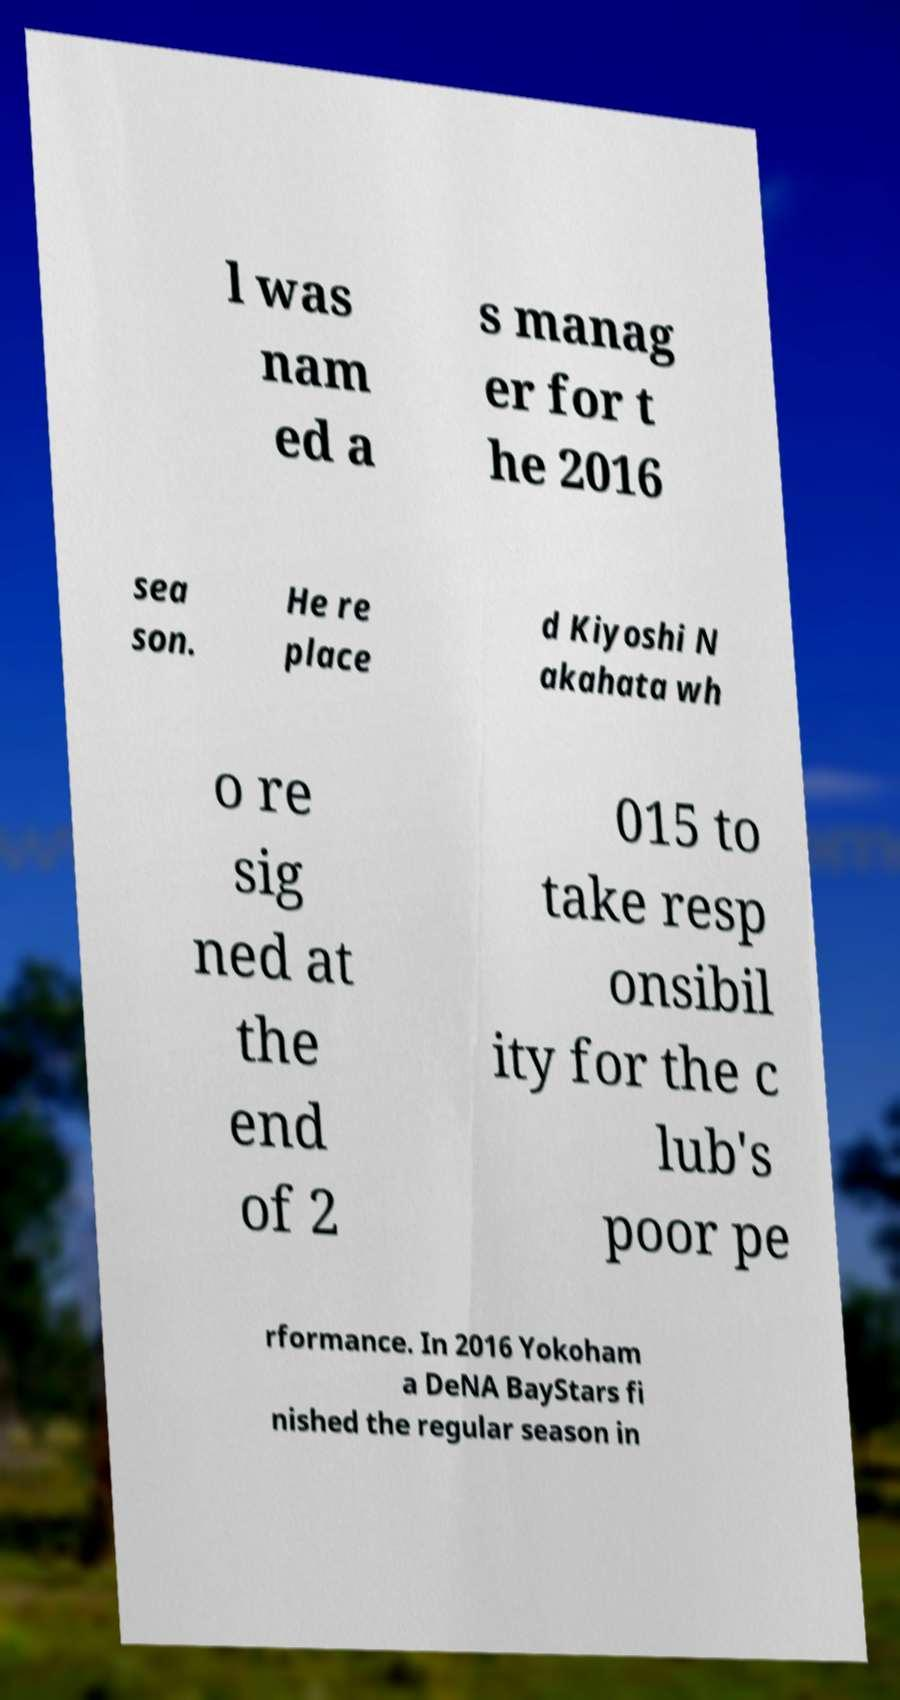For documentation purposes, I need the text within this image transcribed. Could you provide that? l was nam ed a s manag er for t he 2016 sea son. He re place d Kiyoshi N akahata wh o re sig ned at the end of 2 015 to take resp onsibil ity for the c lub's poor pe rformance. In 2016 Yokoham a DeNA BayStars fi nished the regular season in 